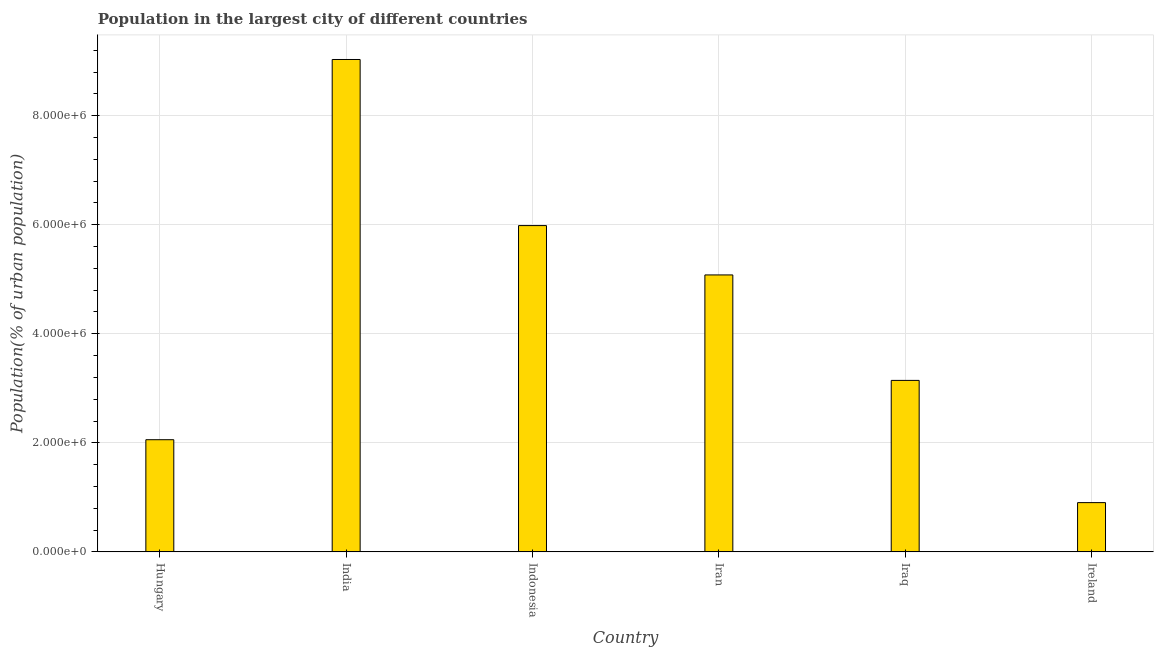Does the graph contain grids?
Your answer should be compact. Yes. What is the title of the graph?
Ensure brevity in your answer.  Population in the largest city of different countries. What is the label or title of the X-axis?
Offer a very short reply. Country. What is the label or title of the Y-axis?
Make the answer very short. Population(% of urban population). What is the population in largest city in Ireland?
Provide a succinct answer. 9.03e+05. Across all countries, what is the maximum population in largest city?
Give a very brief answer. 9.03e+06. Across all countries, what is the minimum population in largest city?
Ensure brevity in your answer.  9.03e+05. In which country was the population in largest city maximum?
Offer a terse response. India. In which country was the population in largest city minimum?
Ensure brevity in your answer.  Ireland. What is the sum of the population in largest city?
Give a very brief answer. 2.62e+07. What is the difference between the population in largest city in India and Indonesia?
Make the answer very short. 3.05e+06. What is the average population in largest city per country?
Give a very brief answer. 4.37e+06. What is the median population in largest city?
Provide a succinct answer. 4.11e+06. In how many countries, is the population in largest city greater than 4000000 %?
Your answer should be compact. 3. What is the ratio of the population in largest city in Indonesia to that in Ireland?
Make the answer very short. 6.62. Is the difference between the population in largest city in India and Ireland greater than the difference between any two countries?
Offer a terse response. Yes. What is the difference between the highest and the second highest population in largest city?
Offer a very short reply. 3.05e+06. What is the difference between the highest and the lowest population in largest city?
Offer a terse response. 8.13e+06. How many bars are there?
Give a very brief answer. 6. Are all the bars in the graph horizontal?
Ensure brevity in your answer.  No. What is the difference between two consecutive major ticks on the Y-axis?
Make the answer very short. 2.00e+06. What is the Population(% of urban population) of Hungary?
Your answer should be very brief. 2.06e+06. What is the Population(% of urban population) of India?
Offer a very short reply. 9.03e+06. What is the Population(% of urban population) of Indonesia?
Offer a very short reply. 5.98e+06. What is the Population(% of urban population) of Iran?
Provide a succinct answer. 5.08e+06. What is the Population(% of urban population) in Iraq?
Keep it short and to the point. 3.14e+06. What is the Population(% of urban population) in Ireland?
Your response must be concise. 9.03e+05. What is the difference between the Population(% of urban population) in Hungary and India?
Your answer should be compact. -6.97e+06. What is the difference between the Population(% of urban population) in Hungary and Indonesia?
Make the answer very short. -3.93e+06. What is the difference between the Population(% of urban population) in Hungary and Iran?
Your answer should be very brief. -3.02e+06. What is the difference between the Population(% of urban population) in Hungary and Iraq?
Keep it short and to the point. -1.09e+06. What is the difference between the Population(% of urban population) in Hungary and Ireland?
Your answer should be very brief. 1.15e+06. What is the difference between the Population(% of urban population) in India and Indonesia?
Give a very brief answer. 3.05e+06. What is the difference between the Population(% of urban population) in India and Iran?
Make the answer very short. 3.95e+06. What is the difference between the Population(% of urban population) in India and Iraq?
Provide a succinct answer. 5.89e+06. What is the difference between the Population(% of urban population) in India and Ireland?
Offer a terse response. 8.13e+06. What is the difference between the Population(% of urban population) in Indonesia and Iran?
Your answer should be compact. 9.05e+05. What is the difference between the Population(% of urban population) in Indonesia and Iraq?
Keep it short and to the point. 2.84e+06. What is the difference between the Population(% of urban population) in Indonesia and Ireland?
Give a very brief answer. 5.08e+06. What is the difference between the Population(% of urban population) in Iran and Iraq?
Your response must be concise. 1.93e+06. What is the difference between the Population(% of urban population) in Iran and Ireland?
Your answer should be very brief. 4.18e+06. What is the difference between the Population(% of urban population) in Iraq and Ireland?
Ensure brevity in your answer.  2.24e+06. What is the ratio of the Population(% of urban population) in Hungary to that in India?
Your answer should be very brief. 0.23. What is the ratio of the Population(% of urban population) in Hungary to that in Indonesia?
Provide a succinct answer. 0.34. What is the ratio of the Population(% of urban population) in Hungary to that in Iran?
Keep it short and to the point. 0.41. What is the ratio of the Population(% of urban population) in Hungary to that in Iraq?
Offer a terse response. 0.65. What is the ratio of the Population(% of urban population) in Hungary to that in Ireland?
Provide a short and direct response. 2.28. What is the ratio of the Population(% of urban population) in India to that in Indonesia?
Make the answer very short. 1.51. What is the ratio of the Population(% of urban population) in India to that in Iran?
Ensure brevity in your answer.  1.78. What is the ratio of the Population(% of urban population) in India to that in Iraq?
Make the answer very short. 2.87. What is the ratio of the Population(% of urban population) in India to that in Ireland?
Ensure brevity in your answer.  9.99. What is the ratio of the Population(% of urban population) in Indonesia to that in Iran?
Offer a very short reply. 1.18. What is the ratio of the Population(% of urban population) in Indonesia to that in Iraq?
Ensure brevity in your answer.  1.9. What is the ratio of the Population(% of urban population) in Indonesia to that in Ireland?
Your response must be concise. 6.62. What is the ratio of the Population(% of urban population) in Iran to that in Iraq?
Provide a succinct answer. 1.61. What is the ratio of the Population(% of urban population) in Iran to that in Ireland?
Make the answer very short. 5.62. What is the ratio of the Population(% of urban population) in Iraq to that in Ireland?
Provide a succinct answer. 3.48. 